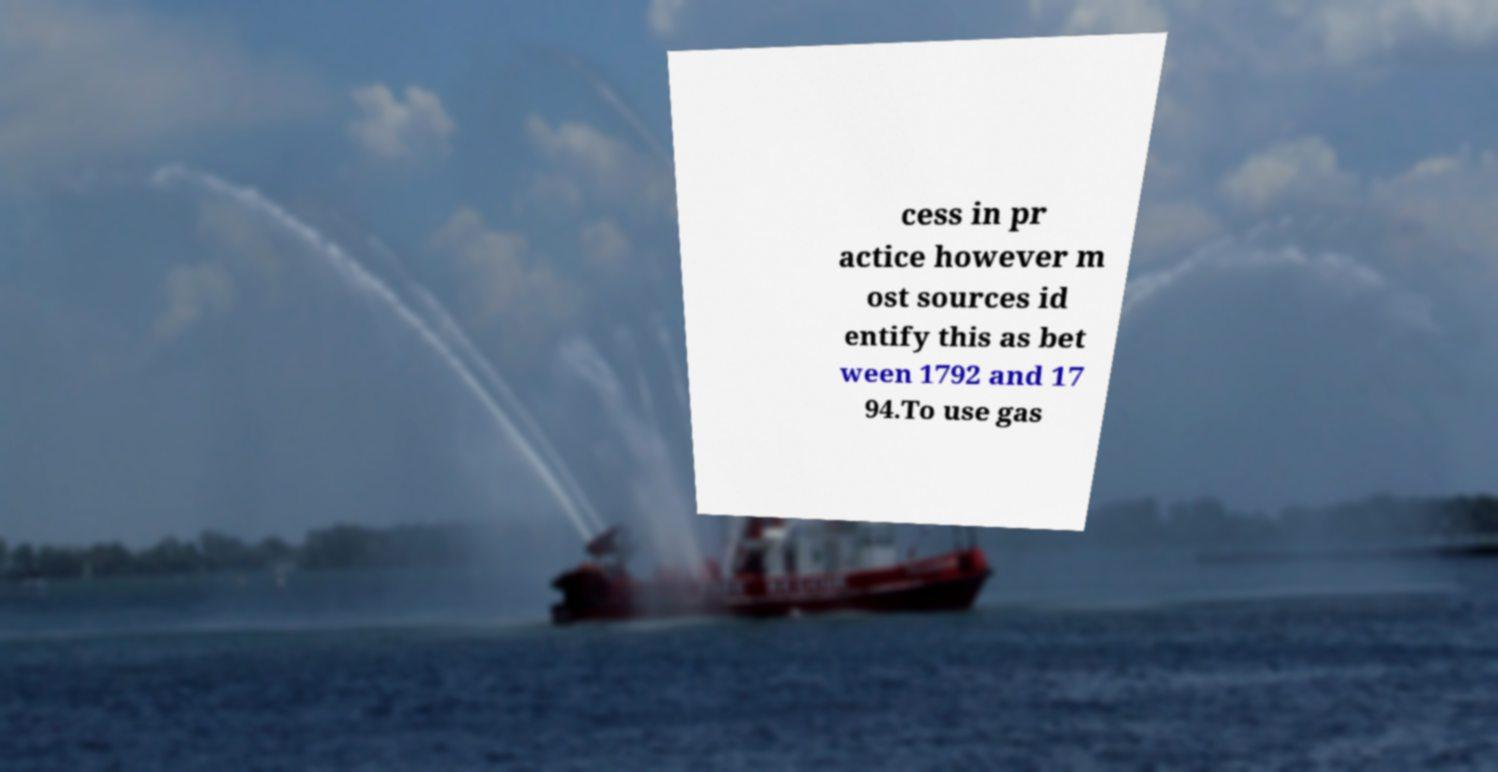What messages or text are displayed in this image? I need them in a readable, typed format. cess in pr actice however m ost sources id entify this as bet ween 1792 and 17 94.To use gas 